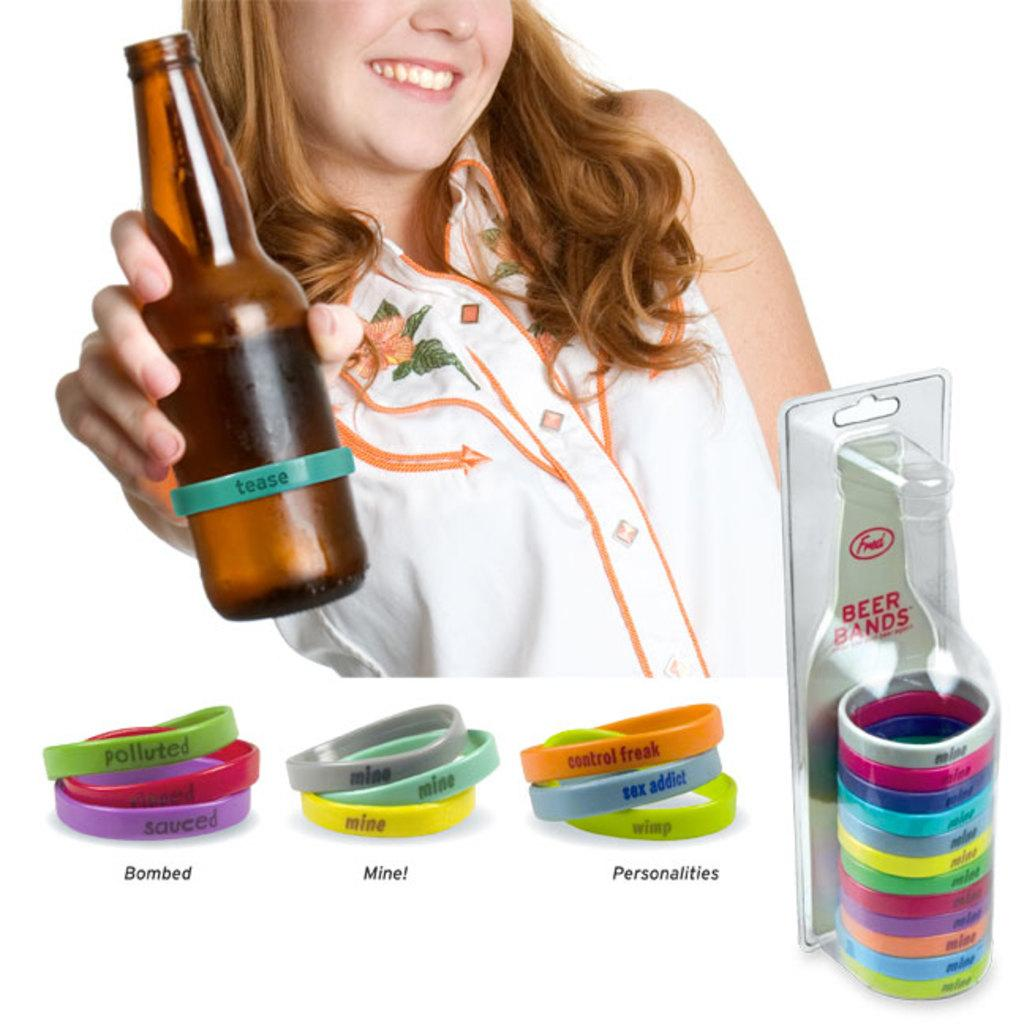Who is present in the image? There is a woman in the image. What is the woman holding in the image? The woman is holding a bottle. What else can be seen in the image besides the woman? There are bands in the image. How are the bands arranged or contained in the image? The bands are packed in a plastic sheet. How many girls are playing the drum in the image? There are no girls or drums present in the image. 